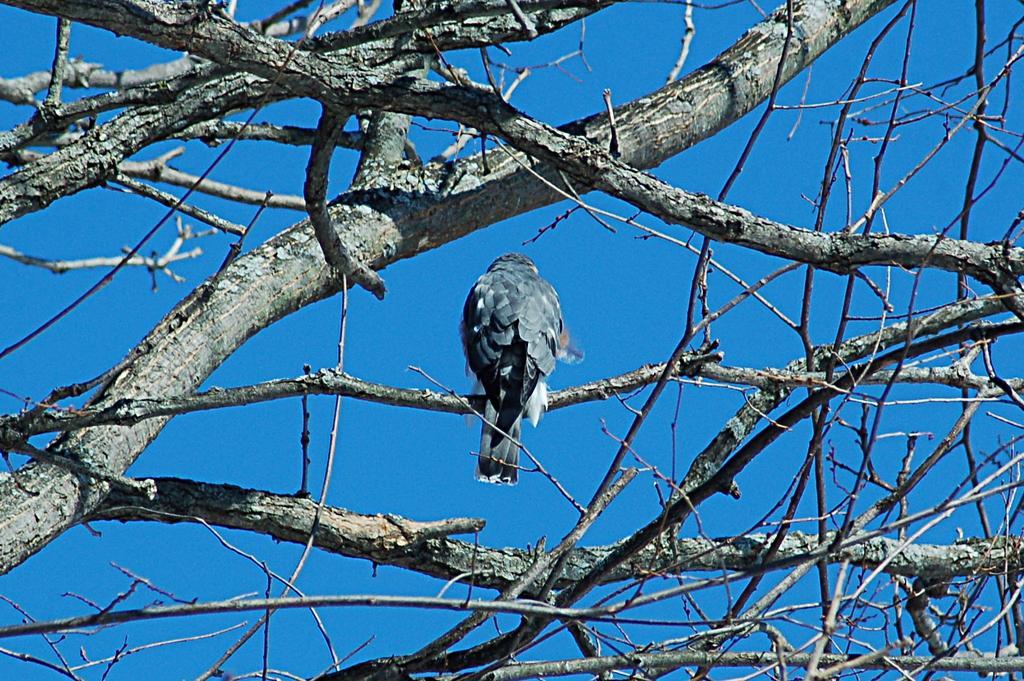Could you give a brief overview of what you see in this image? In this image there is a bird sitting on the branch of the tree and there is a sky. 